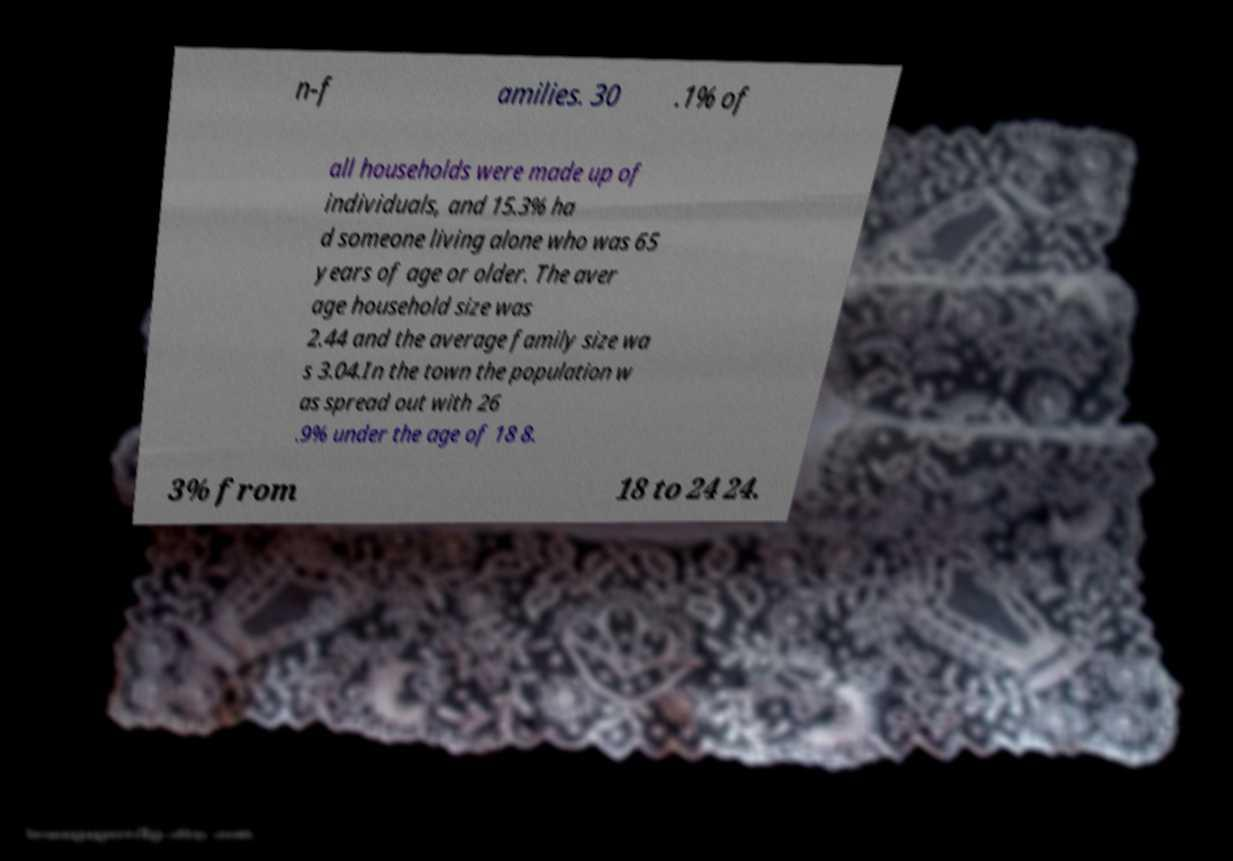Can you accurately transcribe the text from the provided image for me? n-f amilies. 30 .1% of all households were made up of individuals, and 15.3% ha d someone living alone who was 65 years of age or older. The aver age household size was 2.44 and the average family size wa s 3.04.In the town the population w as spread out with 26 .9% under the age of 18 8. 3% from 18 to 24 24. 